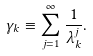Convert formula to latex. <formula><loc_0><loc_0><loc_500><loc_500>\gamma _ { k } \equiv \sum _ { j = 1 } ^ { \infty } \frac { 1 } { \lambda _ { k } ^ { j } } .</formula> 